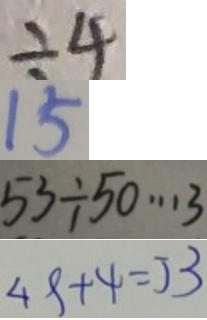<formula> <loc_0><loc_0><loc_500><loc_500>\div 4 
 1 5 
 5 3 \div 5 0 \cdots 3 
 4 9 + 4 = 5 3</formula> 